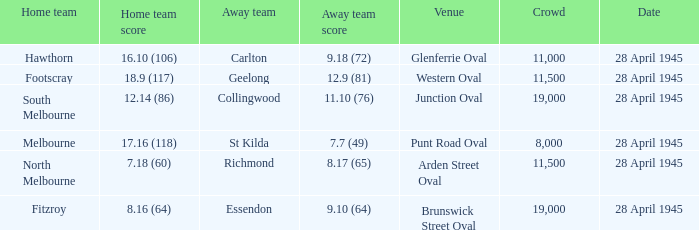What away team played at western oval? Geelong. 